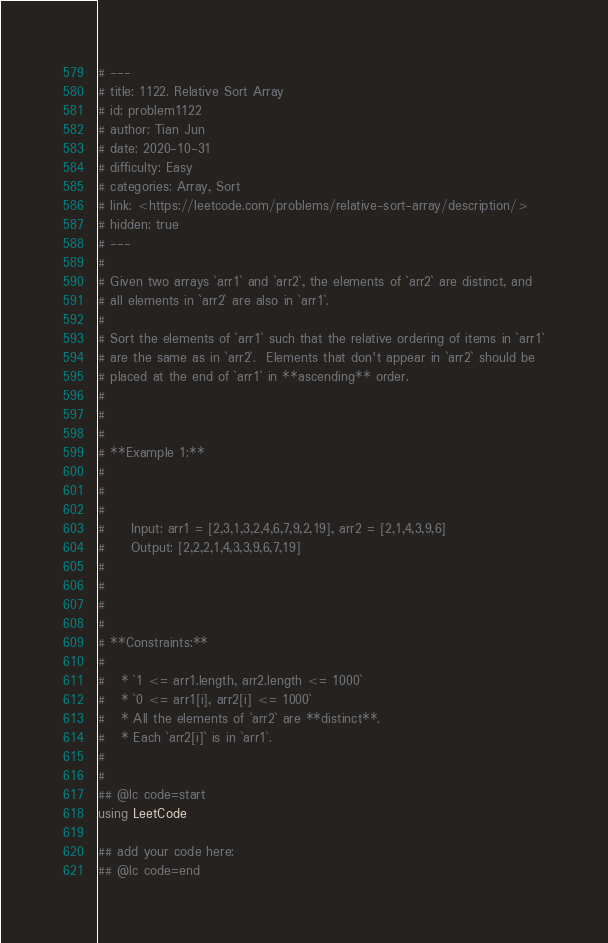Convert code to text. <code><loc_0><loc_0><loc_500><loc_500><_Julia_># ---
# title: 1122. Relative Sort Array
# id: problem1122
# author: Tian Jun
# date: 2020-10-31
# difficulty: Easy
# categories: Array, Sort
# link: <https://leetcode.com/problems/relative-sort-array/description/>
# hidden: true
# ---
# 
# Given two arrays `arr1` and `arr2`, the elements of `arr2` are distinct, and
# all elements in `arr2` are also in `arr1`.
# 
# Sort the elements of `arr1` such that the relative ordering of items in `arr1`
# are the same as in `arr2`.  Elements that don't appear in `arr2` should be
# placed at the end of `arr1` in **ascending** order.
# 
# 
# 
# **Example 1:**
# 
#     
#     
#     Input: arr1 = [2,3,1,3,2,4,6,7,9,2,19], arr2 = [2,1,4,3,9,6]
#     Output: [2,2,2,1,4,3,3,9,6,7,19]
#     
# 
# 
# 
# **Constraints:**
# 
#   * `1 <= arr1.length, arr2.length <= 1000`
#   * `0 <= arr1[i], arr2[i] <= 1000`
#   * All the elements of `arr2` are **distinct**.
#   * Each `arr2[i]` is in `arr1`.
# 
# 
## @lc code=start
using LeetCode

## add your code here:
## @lc code=end
</code> 